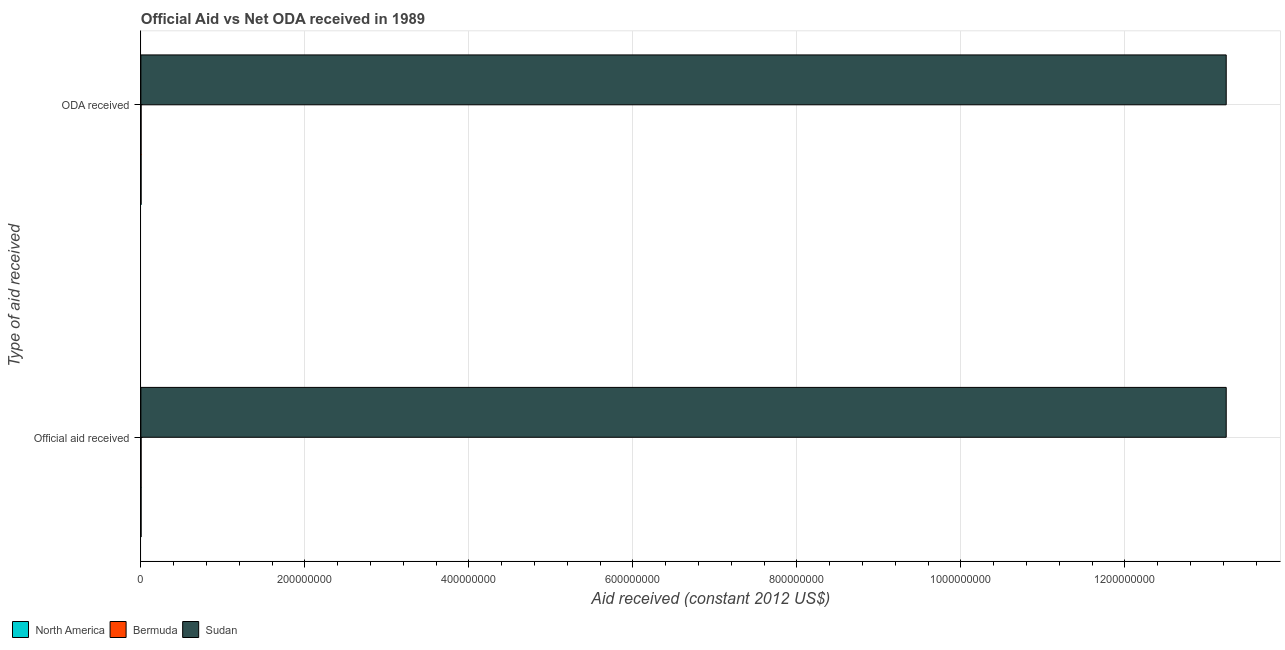How many groups of bars are there?
Offer a very short reply. 2. Are the number of bars on each tick of the Y-axis equal?
Offer a very short reply. Yes. How many bars are there on the 2nd tick from the top?
Give a very brief answer. 3. How many bars are there on the 1st tick from the bottom?
Make the answer very short. 3. What is the label of the 2nd group of bars from the top?
Offer a terse response. Official aid received. What is the oda received in Bermuda?
Keep it short and to the point. 2.10e+05. Across all countries, what is the maximum official aid received?
Provide a short and direct response. 1.32e+09. Across all countries, what is the minimum oda received?
Provide a succinct answer. 2.10e+05. In which country was the oda received maximum?
Your response must be concise. Sudan. What is the total official aid received in the graph?
Provide a short and direct response. 1.32e+09. What is the difference between the oda received in Sudan and that in North America?
Make the answer very short. 1.32e+09. What is the difference between the oda received in Bermuda and the official aid received in Sudan?
Ensure brevity in your answer.  -1.32e+09. What is the average official aid received per country?
Provide a short and direct response. 4.41e+08. What is the difference between the official aid received and oda received in Bermuda?
Offer a very short reply. 0. In how many countries, is the oda received greater than 1280000000 US$?
Keep it short and to the point. 1. What is the ratio of the official aid received in North America to that in Sudan?
Your answer should be very brief. 0. In how many countries, is the oda received greater than the average oda received taken over all countries?
Offer a very short reply. 1. What does the 1st bar from the top in Official aid received represents?
Ensure brevity in your answer.  Sudan. What does the 3rd bar from the bottom in Official aid received represents?
Your response must be concise. Sudan. Are all the bars in the graph horizontal?
Your answer should be very brief. Yes. How many countries are there in the graph?
Keep it short and to the point. 3. What is the difference between two consecutive major ticks on the X-axis?
Ensure brevity in your answer.  2.00e+08. Are the values on the major ticks of X-axis written in scientific E-notation?
Keep it short and to the point. No. Does the graph contain any zero values?
Give a very brief answer. No. Where does the legend appear in the graph?
Your answer should be very brief. Bottom left. How many legend labels are there?
Provide a succinct answer. 3. What is the title of the graph?
Ensure brevity in your answer.  Official Aid vs Net ODA received in 1989 . Does "Turkey" appear as one of the legend labels in the graph?
Your answer should be very brief. No. What is the label or title of the X-axis?
Offer a very short reply. Aid received (constant 2012 US$). What is the label or title of the Y-axis?
Provide a succinct answer. Type of aid received. What is the Aid received (constant 2012 US$) of North America in Official aid received?
Provide a succinct answer. 2.10e+05. What is the Aid received (constant 2012 US$) in Bermuda in Official aid received?
Offer a very short reply. 2.10e+05. What is the Aid received (constant 2012 US$) of Sudan in Official aid received?
Your answer should be very brief. 1.32e+09. What is the Aid received (constant 2012 US$) in Bermuda in ODA received?
Provide a short and direct response. 2.10e+05. What is the Aid received (constant 2012 US$) in Sudan in ODA received?
Your answer should be compact. 1.32e+09. Across all Type of aid received, what is the maximum Aid received (constant 2012 US$) of North America?
Offer a very short reply. 2.10e+05. Across all Type of aid received, what is the maximum Aid received (constant 2012 US$) in Sudan?
Your answer should be very brief. 1.32e+09. Across all Type of aid received, what is the minimum Aid received (constant 2012 US$) in Bermuda?
Keep it short and to the point. 2.10e+05. Across all Type of aid received, what is the minimum Aid received (constant 2012 US$) in Sudan?
Offer a terse response. 1.32e+09. What is the total Aid received (constant 2012 US$) in North America in the graph?
Your answer should be compact. 4.20e+05. What is the total Aid received (constant 2012 US$) in Bermuda in the graph?
Offer a very short reply. 4.20e+05. What is the total Aid received (constant 2012 US$) in Sudan in the graph?
Offer a very short reply. 2.65e+09. What is the difference between the Aid received (constant 2012 US$) in North America in Official aid received and that in ODA received?
Provide a succinct answer. 0. What is the difference between the Aid received (constant 2012 US$) in Sudan in Official aid received and that in ODA received?
Offer a terse response. 0. What is the difference between the Aid received (constant 2012 US$) of North America in Official aid received and the Aid received (constant 2012 US$) of Sudan in ODA received?
Offer a very short reply. -1.32e+09. What is the difference between the Aid received (constant 2012 US$) in Bermuda in Official aid received and the Aid received (constant 2012 US$) in Sudan in ODA received?
Provide a short and direct response. -1.32e+09. What is the average Aid received (constant 2012 US$) in North America per Type of aid received?
Your answer should be compact. 2.10e+05. What is the average Aid received (constant 2012 US$) of Bermuda per Type of aid received?
Keep it short and to the point. 2.10e+05. What is the average Aid received (constant 2012 US$) of Sudan per Type of aid received?
Give a very brief answer. 1.32e+09. What is the difference between the Aid received (constant 2012 US$) in North America and Aid received (constant 2012 US$) in Bermuda in Official aid received?
Offer a terse response. 0. What is the difference between the Aid received (constant 2012 US$) of North America and Aid received (constant 2012 US$) of Sudan in Official aid received?
Your answer should be compact. -1.32e+09. What is the difference between the Aid received (constant 2012 US$) in Bermuda and Aid received (constant 2012 US$) in Sudan in Official aid received?
Your response must be concise. -1.32e+09. What is the difference between the Aid received (constant 2012 US$) of North America and Aid received (constant 2012 US$) of Sudan in ODA received?
Offer a terse response. -1.32e+09. What is the difference between the Aid received (constant 2012 US$) in Bermuda and Aid received (constant 2012 US$) in Sudan in ODA received?
Make the answer very short. -1.32e+09. What is the ratio of the Aid received (constant 2012 US$) of Bermuda in Official aid received to that in ODA received?
Ensure brevity in your answer.  1. What is the ratio of the Aid received (constant 2012 US$) in Sudan in Official aid received to that in ODA received?
Offer a very short reply. 1. What is the difference between the highest and the second highest Aid received (constant 2012 US$) in North America?
Make the answer very short. 0. What is the difference between the highest and the second highest Aid received (constant 2012 US$) in Sudan?
Your answer should be very brief. 0. What is the difference between the highest and the lowest Aid received (constant 2012 US$) of Bermuda?
Your answer should be compact. 0. 